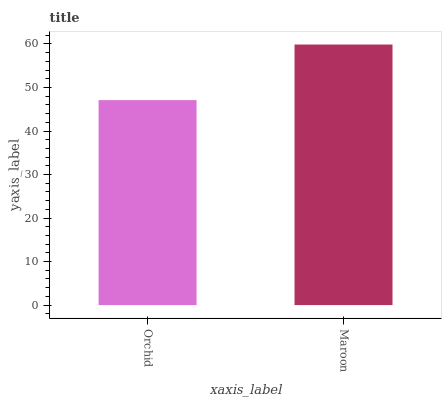Is Orchid the minimum?
Answer yes or no. Yes. Is Maroon the maximum?
Answer yes or no. Yes. Is Maroon the minimum?
Answer yes or no. No. Is Maroon greater than Orchid?
Answer yes or no. Yes. Is Orchid less than Maroon?
Answer yes or no. Yes. Is Orchid greater than Maroon?
Answer yes or no. No. Is Maroon less than Orchid?
Answer yes or no. No. Is Maroon the high median?
Answer yes or no. Yes. Is Orchid the low median?
Answer yes or no. Yes. Is Orchid the high median?
Answer yes or no. No. Is Maroon the low median?
Answer yes or no. No. 